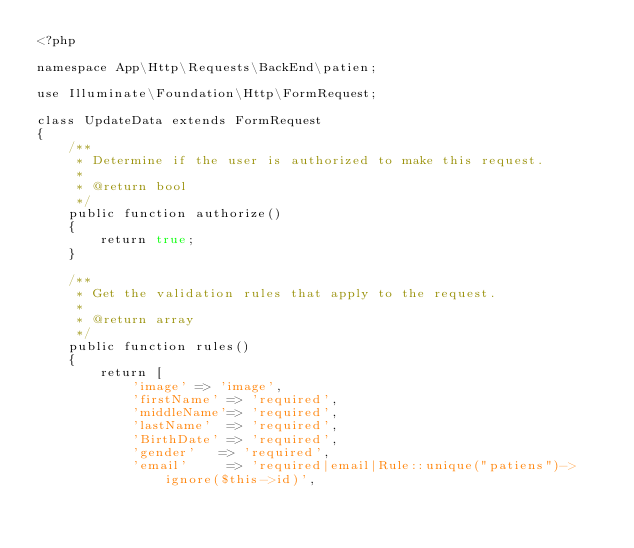<code> <loc_0><loc_0><loc_500><loc_500><_PHP_><?php

namespace App\Http\Requests\BackEnd\patien;

use Illuminate\Foundation\Http\FormRequest;

class UpdateData extends FormRequest
{
    /**
     * Determine if the user is authorized to make this request.
     *
     * @return bool
     */
    public function authorize()
    {
        return true;
    }

    /**
     * Get the validation rules that apply to the request.
     *
     * @return array
     */
    public function rules()
    {
        return [
            'image' => 'image',
            'firstName' => 'required',
            'middleName'=> 'required',
            'lastName'  => 'required',
            'BirthDate' => 'required',
            'gender'   => 'required',
            'email'     => 'required|email|Rule::unique("patiens")->ignore($this->id)',</code> 